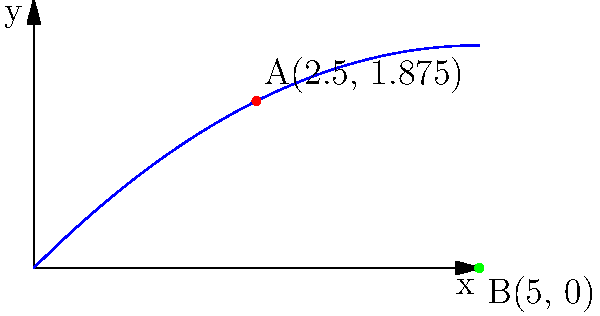As an amputee testing an advanced prosthetic arm, you're analyzing its movement trajectory. The arm's path from point A to point B is modeled by the parametric equations: $x(t) = t$ and $y(t) = -0.1t^2 + t$, where $t$ is time in seconds. Point A is reached at $t = 2.5s$ and point B at $t = 5s$. What is the prosthetic arm's velocity vector $\vec{v}$ (in m/s) at point A? To find the velocity vector at point A, we need to follow these steps:

1) The velocity vector is given by $\vec{v} = (\frac{dx}{dt}, \frac{dy}{dt})$.

2) Calculate $\frac{dx}{dt}$:
   $x(t) = t$
   $\frac{dx}{dt} = 1$

3) Calculate $\frac{dy}{dt}$:
   $y(t) = -0.1t^2 + t$
   $\frac{dy}{dt} = -0.2t + 1$

4) The velocity vector is therefore:
   $\vec{v} = (1, -0.2t + 1)$

5) At point A, $t = 2.5s$. Substitute this into the velocity vector:
   $\vec{v}_A = (1, -0.2(2.5) + 1)$
   $\vec{v}_A = (1, -0.5 + 1)$
   $\vec{v}_A = (1, 0.5)$

Therefore, the velocity vector at point A is $(1, 0.5)$ m/s.
Answer: $(1, 0.5)$ m/s 